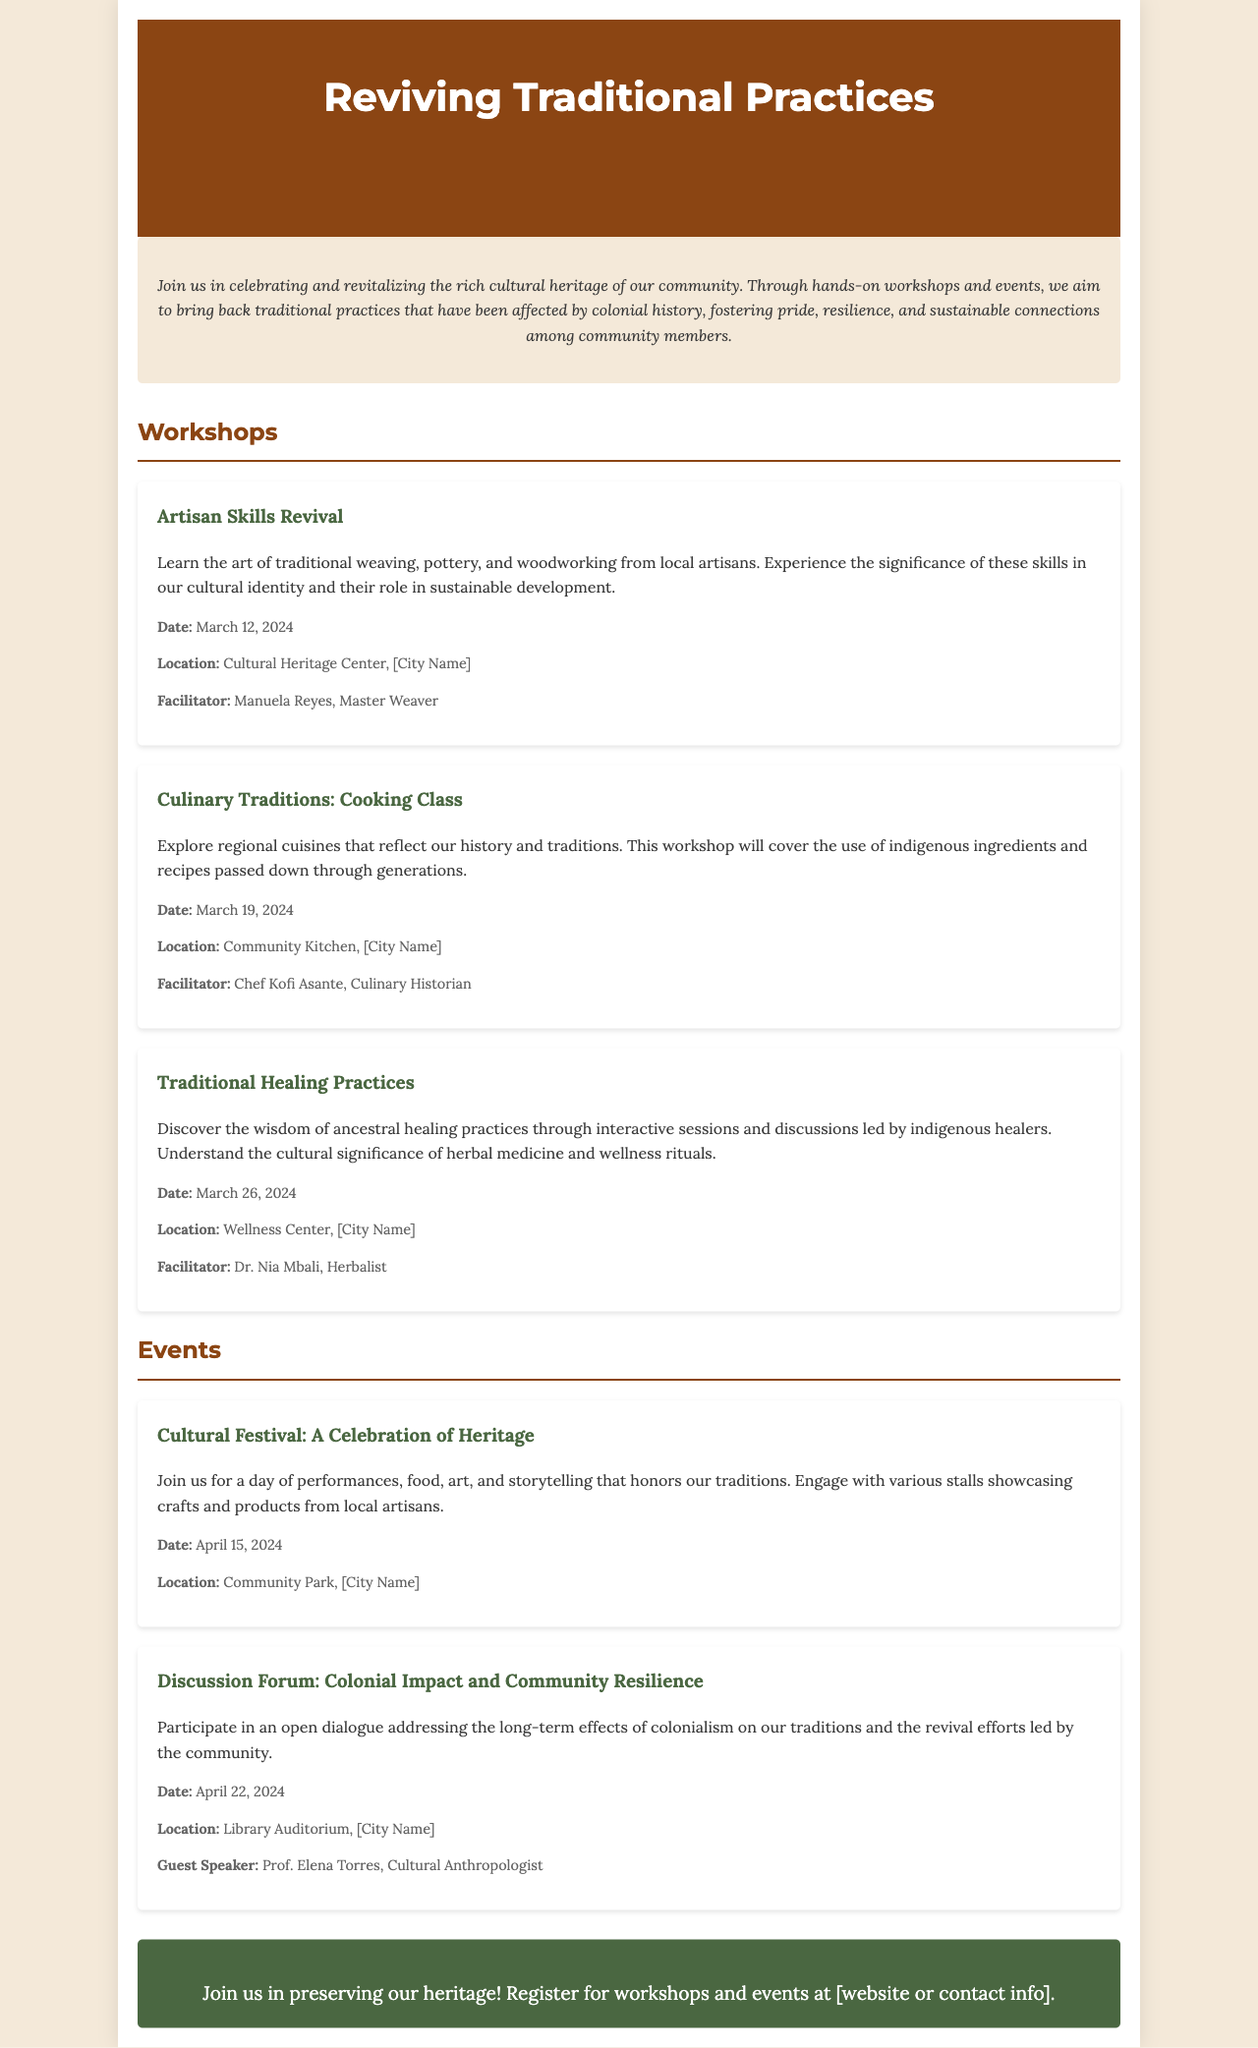what is the title of the brochure? The title of the brochure is prominently displayed at the top, identifying the main topic of the document.
Answer: Reviving Traditional Practices who is the facilitator for the "Artisan Skills Revival" workshop? The facilitator's name is included in the workshop details, indicating who will lead the session.
Answer: Manuela Reyes when is the "Culinary Traditions: Cooking Class" workshop scheduled? The specific date for the workshop is mentioned in the workshop details section.
Answer: March 19, 2024 where will the "Cultural Festival: A Celebration of Heritage" event take place? The location of the event is provided in the event details section.
Answer: Community Park, [City Name] what theme does the "Discussion Forum: Colonial Impact and Community Resilience" address? The theme of the discussion forum is stated, highlighting its focus on a particular topic related to colonialism.
Answer: Colonial impact and community resilience how many workshops are listed in the brochure? The total number of workshops can be counted from the sections describing different workshops in the document.
Answer: Three what is the date of the "Cultural Festival"? The date for the event can be found in its detailed description under the events section.
Answer: April 15, 2024 who is the guest speaker for the "Discussion Forum"? The document specifies the name of the guest speaker associated with the forum in the event details.
Answer: Prof. Elena Torres 